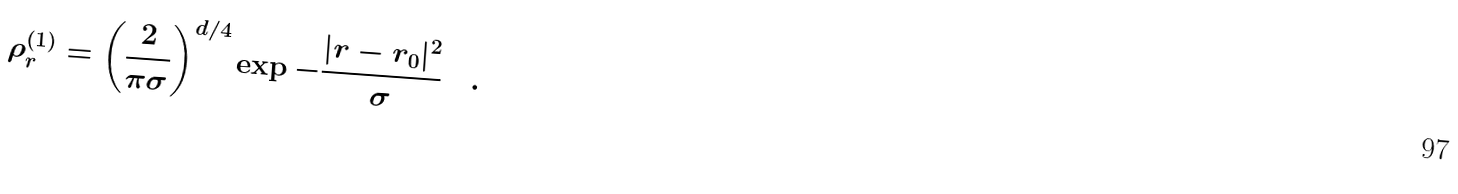Convert formula to latex. <formula><loc_0><loc_0><loc_500><loc_500>\rho ^ { ( 1 ) } _ { r } = \left ( \frac { 2 } { \pi \sigma } \right ) ^ { d / 4 } \exp { - \frac { | r - r _ { 0 } | ^ { 2 } } { \sigma } } \quad .</formula> 